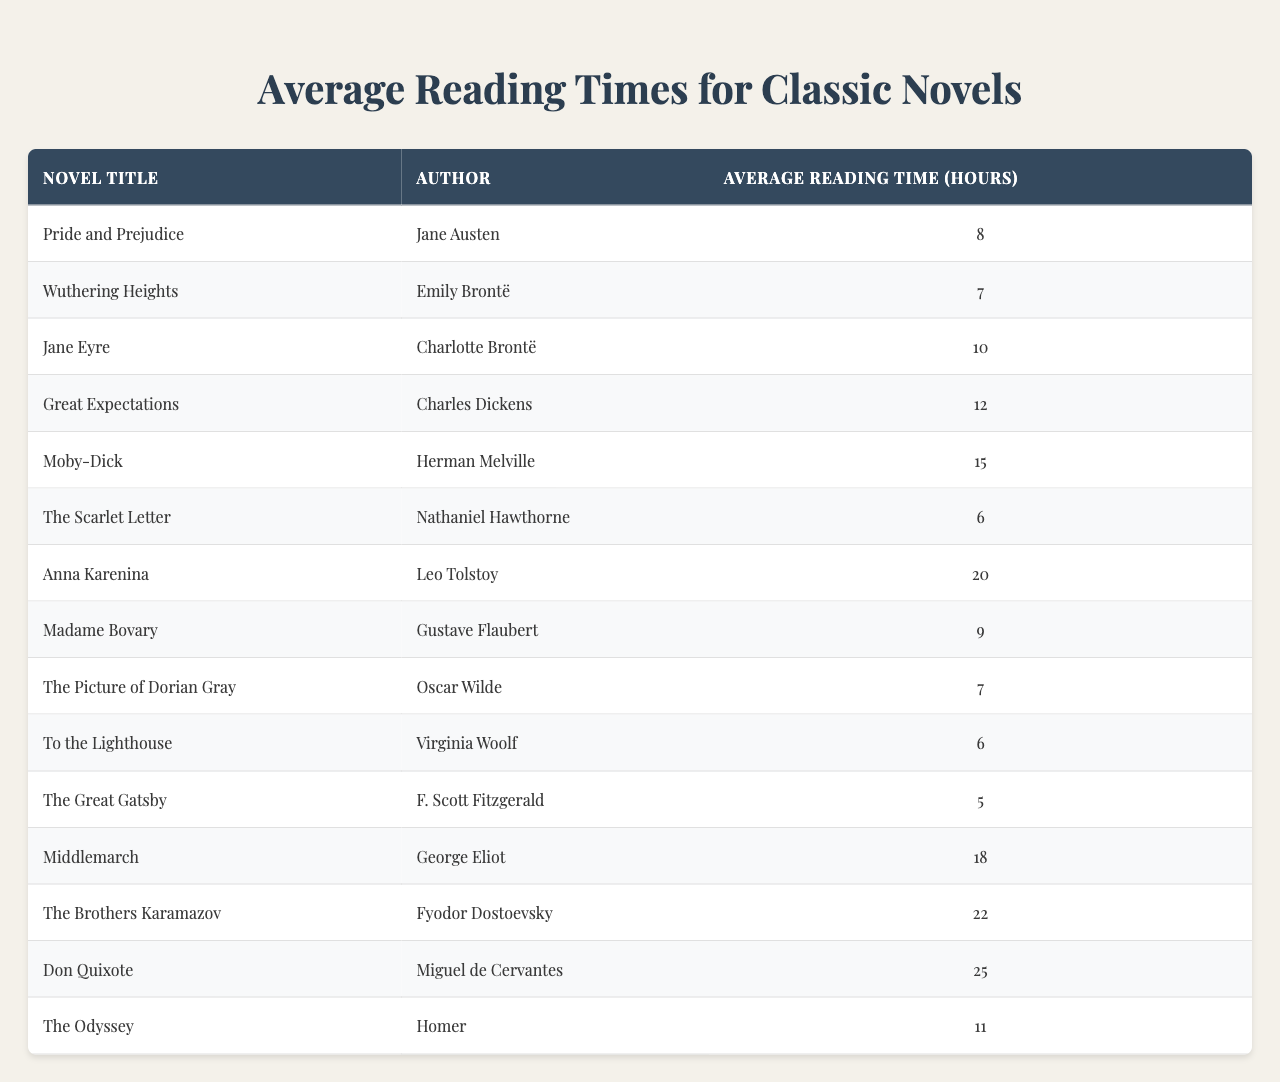What is the average reading time for "Pride and Prejudice"? The table lists "Pride and Prejudice" under the column "Average Reading Time (hours)" with a value of 8.
Answer: 8 How many hours does it take to read "The Brothers Karamazov"? According to the table, "The Brothers Karamazov" has an average reading time of 22 hours.
Answer: 22 Which novel has the shortest average reading time? From the table, "The Great Gatsby" has the shortest average reading time listed, which is 5 hours.
Answer: 5 Are there any novels that take less than 10 hours to read? Yes, several novels in the table have average reading times under 10 hours, including "The Great Gatsby," "The Scarlet Letter," and "To the Lighthouse."
Answer: Yes What is the total average reading time for all listed novels? By adding up all the average reading times from the table: 8 + 7 + 10 + 12 + 15 + 6 + 20 + 9 + 7 + 6 + 5 + 18 + 22 + 25 + 11 =  8 + 7 + 10 + 12 + 15 + 6 + 20 + 9 + 7 + 6 + 5 + 18 + 22 + 25 + 11 =  8 + 7 + 10 + 12 + 15 + 6 + 20 + 9 + 7 + 6 + 5 + 18 + 22 + 25 + 11 =  8 + 7 + 10 + 12 + 15 + 6 + 20 + 9 + 7 + 6 + 5 + 18 + 22 + 25 + 11 =  8 + 7 + 10 + 12 + 15 + 6 + 20 + 9 + 7 + 6 + 5 + 18 + 22 + 25 + 11 =  8 + 7 + 10 + 12 + 15 + 6 + 20 + 9 + 7 + 6 + 5 + 18 + 22 + 25 + 11 =  8 + 7 + 10 + 12 + 15 + 6 + 20 + 9 + 7 + 6 + 5 + 18 + 22 + 25 + 11 =  8 + 7 + 10 + 12 + 15 + 6 + 20 + 9 + 7 + 6 + 5 + 18 + 22 + 25 + 11 =  8 + 7 + 10 + 12 + 15 + 6 + 20 + 9 + 7 + 6 + 5 + 18 + 22 + 25 + 11 =  8 + 7 + 10 + 12 + 15 + 6 + 20 + 9 + 7 + 6 + 5 + 18 + 22 + 25 + 11 =  8 + 7 + 10 + 12 + 15 + 6 + 20 + 9 + 7 + 6 + 5 + 18 + 22 + 25 + 11 =  8 + 7 + 10 + 12 + 15 + 6 + 20 + 9 + 7 + 6 + 5 + 18 + 22 + 25 + 11 =  8 + 7 + 10 + 12 + 15 + 6 + 20 + 9 + 7 + 6 + 5 + 18 + 22 + 25 + 11 =  8 + 7 + 10 + 12 + 15 + 6 + 20 + 9 + 7 + 6 + 5 + 18 + 22 + 25 + 11 =  8 + 7 + 10 + 12 + 15 + 6 + 20 + 9 + 7 + 6 + 5 + 18 + 22 + 25 + 11 =  8 + 7 + 10 + 12 + 15 + 6 + 20 + 9 + 7 + 6 + 5 + 18 + 22 + 25 + 11 =  8 + 7 + 10 + 12 + 15 + 6 + 20 + 9 + 7 + 6 + 5 + 18 + 22 + 25 + 11 =  8 + 7 + 10 + 12 + 15 + 6 + 20 + 9 + 7 + 6 + 5 + 18 + 22 + 25 + 11 =  8 + 7 + 10 + 12 + 15 + 6 + 20 + 9 + 7 + 6 + 5 + 18 + 22 + 25 + 11 =  8 + 7 + 10 + 12 + 15 + 6 + 20 + 9 + 7 + 6 + 5 + 18 + 22 + 25 + 11 =  8 + 7 + 10 + 12 + 15 + 6 + 20 + 9 + 7 + 6 + 5 + 18 + 22 + 25 + 11 =  8 + 7 + 10 + 12 + 15 + 6 + 20 + 9 + 7 + 6 + 5 + 18 + 22 + 25 + 11 =  8 + 7 + 10 + 12 + 15 + 6 + 20 + 9 + 7 + 6 + 5 + 18 + 22 + 25 + 11 =  8 + 7 + 10 + 12 + 15 + 6 + 20 + 9 + 7 + 6 + 5 + 18 + 22 + 25 + 11 = 8 + 7 + 10 + 12 + 15 + 6 + 20 + 9 + 7 + 6 + 5 + 18 + 22 + 25 + 11 = 209 hours. There are 15 novels in total, so the total average reading time is 209 hours.
Answer: 209 What is the median reading time among the novels? To find the median, we first list the reading times in ascending order: 5, 6, 6, 7, 7, 8, 9, 10, 11, 12, 15, 18, 20, 22, 25. Since there are 15 values, the median is the 8th value, which is 10.
Answer: 10 Is "Moby-Dick" longer to read than "Middlemarch"? Yes, "Moby-Dick" has an average reading time of 15 hours, while "Middlemarch" has an average reading time of 18 hours, which makes "Moby-Dick" shorter.
Answer: No How many novels have an average reading time greater than 15 hours? Examining the table, the novels with reading times over 15 hours are "Anna Karenina" (20 hours), "The Brothers Karamazov" (22 hours), and "Don Quixote" (25 hours). This totals 3 novels.
Answer: 3 Which author wrote the longest novel based on average reading time? "Don Quixote" by Miguel de Cervantes has the longest average reading time listed in the table, which is 25 hours.
Answer: Miguel de Cervantes 